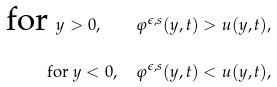Convert formula to latex. <formula><loc_0><loc_0><loc_500><loc_500>\text { for } y > 0 , \quad \varphi ^ { \epsilon , s } ( y , t ) > u ( y , t ) , \\ \text { for } y < 0 , \quad \varphi ^ { \epsilon , s } ( y , t ) < u ( y , t ) ,</formula> 